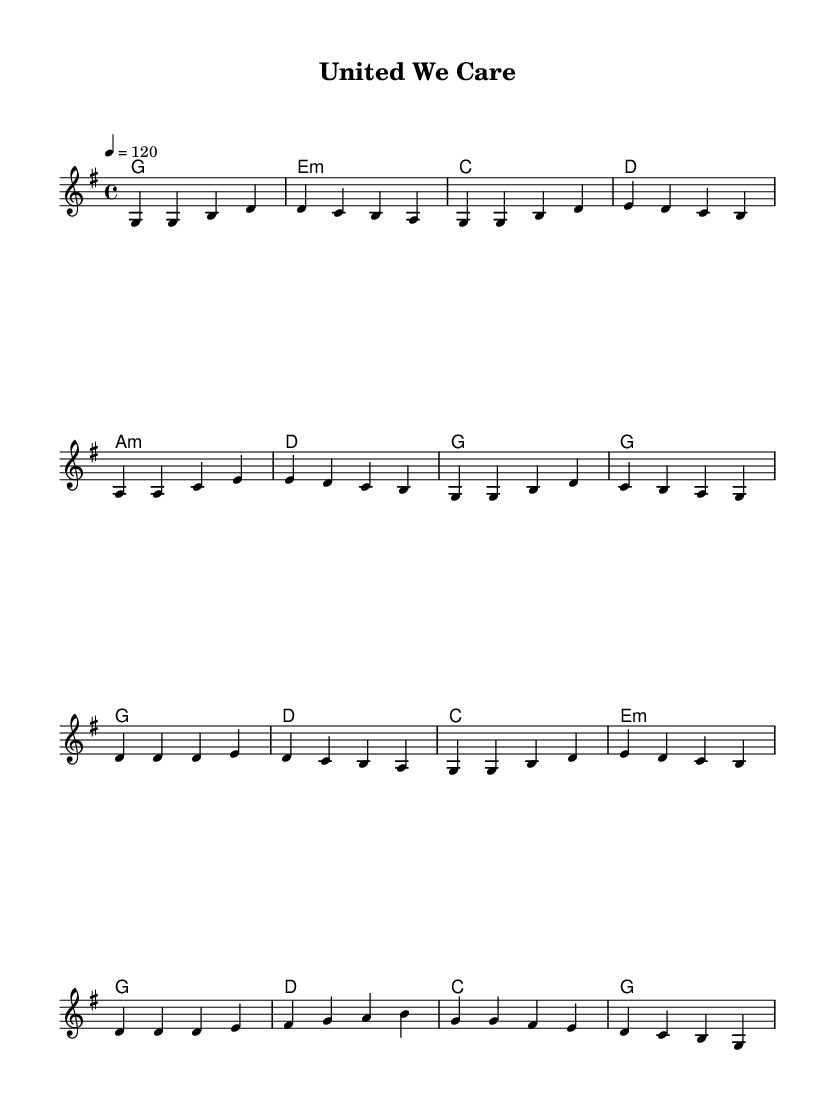What is the key signature of this music? The key signature is G major, which has one sharp (F#). You can find this indicated at the beginning of the staff.
Answer: G major What is the time signature of this music? The time signature is 4/4, which can be seen at the beginning of the score. This means there are four beats in each measure.
Answer: 4/4 What is the tempo marking of the piece? The tempo marking is 120 beats per minute, indicated within the tempo directive at the start of the score.
Answer: 120 How many measures are in the verse? The verse consists of 8 measures, which can be counted as you observe the musical notation and the separation of phrases.
Answer: 8 How many different chords are used in the chorus? There are four different chords used in the chorus: G, D, C, and E minor. This is determined by looking at the chord symbols above the melody.
Answer: 4 What is the emotional theme represented in the lyrics? The emotional theme of the lyrics focuses on unity and perseverance in the face of challenges, as expressed through the lyrics that speak to standing together and overcoming difficulties.
Answer: Unity and perseverance What is the main message conveyed in the chorus words? The main message conveyed in the chorus words highlights the importance of staying united and pushing through tough times, emphasizing collective strength.
Answer: Staying united 